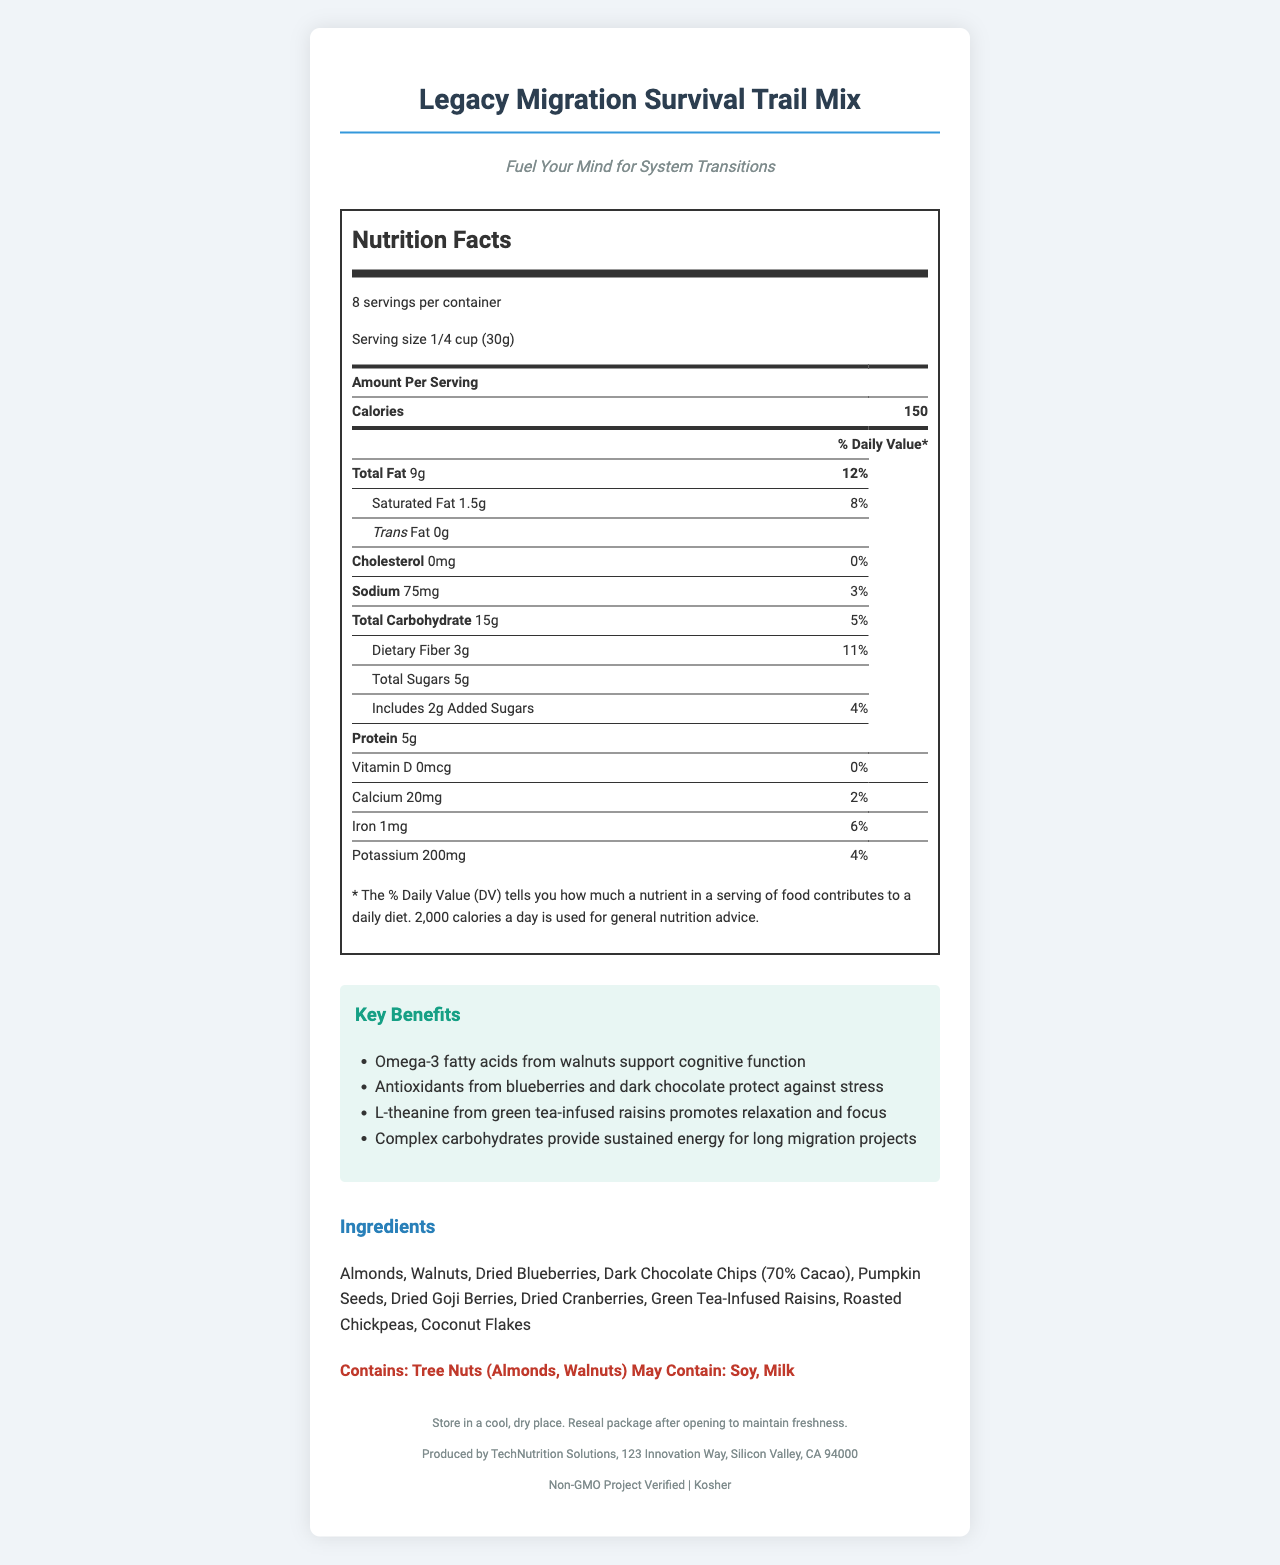what is the serving size? The document states that the serving size is 1/4 cup (30g).
Answer: 1/4 cup (30g) how many calories are in one serving? The calories per serving are listed as 150.
Answer: 150 how much saturated fat is in one serving? The amount of saturated fat per serving is recorded as 1.5g.
Answer: 1.5g what is the percentage of the daily value of sodium per serving? The sodium daily value percentage for a serving is listed as 3%.
Answer: 3% how many grams of protein are in each serving? Each serving contains 5g of protein.
Answer: 5g what are the main ingredients in the "Legacy Migration Survival Trail Mix"? The ingredients section lists these items as the main components of the trail mix.
Answer: Almonds, Walnuts, Dried Blueberries, Dark Chocolate Chips (70% Cacao), Pumpkin Seeds, Dried Goji Berries, Dried Cranberries, Green Tea-Infused Raisins, Roasted Chickpeas, Coconut Flakes what allergens should consumers be aware of? The allergens section mentions the presence of tree nuts and the possible presence of soy and milk.
Answer: Contains: Tree Nuts (Almonds, Walnuts) May Contain: Soy, Milk which of these certifications does the trail mix have? A. USDA Organic B. Gluten-Free C. Non-GMO Project Verified D. Halal The document mentions that the trail mix is Non-GMO Project Verified.
Answer: C which benefit is provided by the green tea-infused raisins in the trail mix? A. Supports cognitive function B. Protects against stress C. Promotes relaxation and focus D. Provides sustained energy The benefit provided by green tea-infused raisins is promoting relaxation and focus.
Answer: C is the trail mix suitable for individuals avoiding cholesterol? The document states that the trail mix contains 0mg of cholesterol per serving.
Answer: Yes describe the main idea of the "Legacy Migration Survival Trail Mix" document The main idea is to present the comprehensive nutritional profile and benefits of the trail mix designed to support mental performance during system transitions.
Answer: The document provides detailed information about the nutritional facts, ingredients, key benefits, allergens, storage instructions, and certifications for the "Legacy Migration Survival Trail Mix" designed to fuel the mind for system transitions. can you determine the total volume of the package based on the information provided? The document does not provide the total volume or weight of the package, only the serving size and number of servings per container.
Answer: Not enough information 